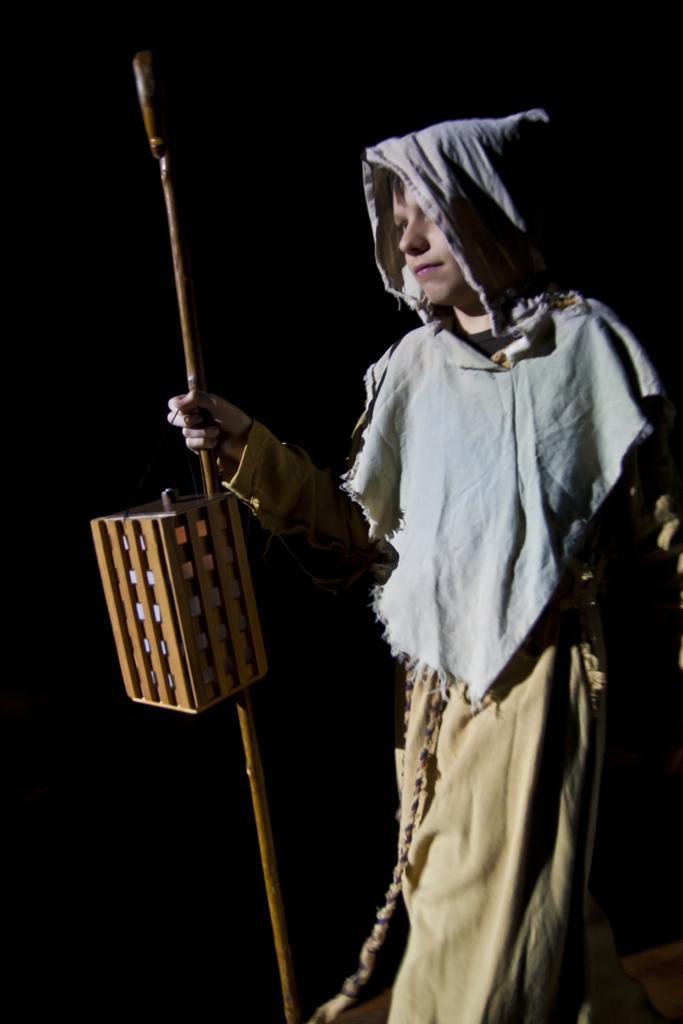Can you describe this image briefly? In this image, we can see a person is holding a stick and lantern. At the bottom, we can see a floor. 